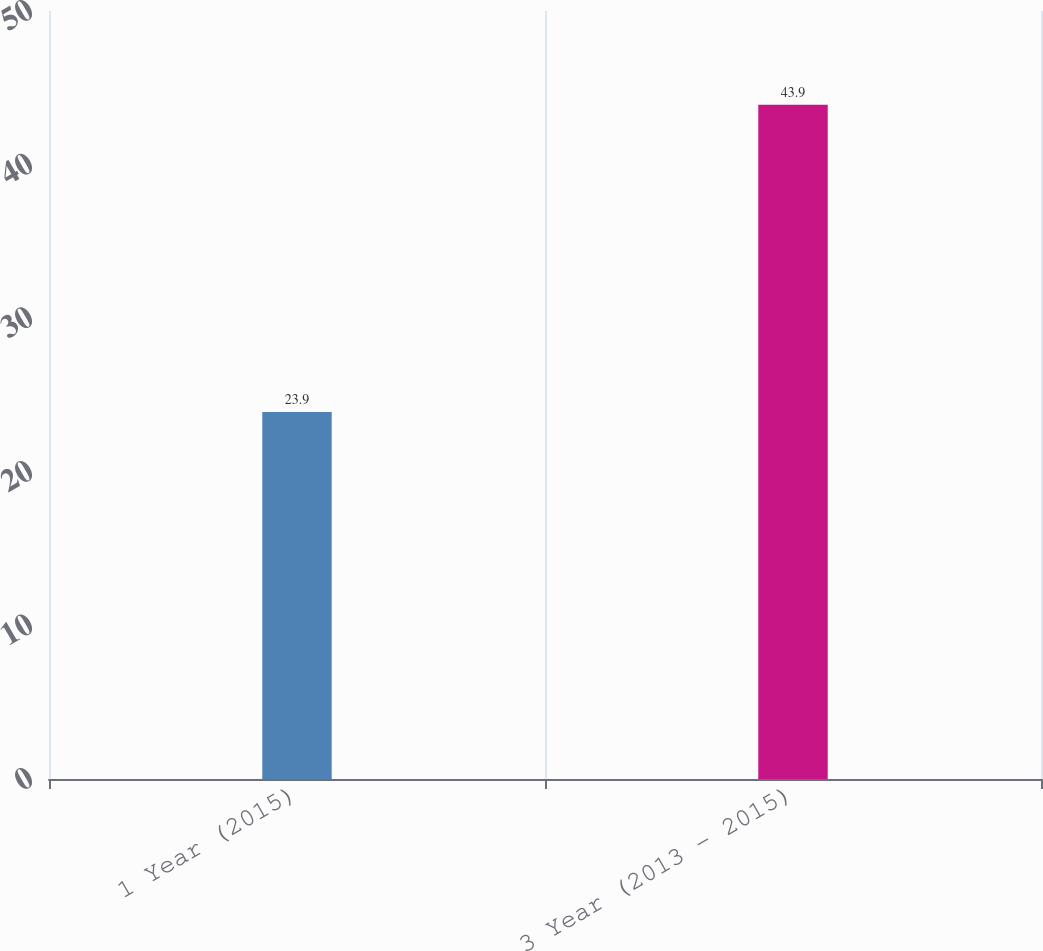Convert chart to OTSL. <chart><loc_0><loc_0><loc_500><loc_500><bar_chart><fcel>1 Year (2015)<fcel>3 Year (2013 - 2015)<nl><fcel>23.9<fcel>43.9<nl></chart> 